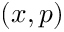Convert formula to latex. <formula><loc_0><loc_0><loc_500><loc_500>( x , p )</formula> 